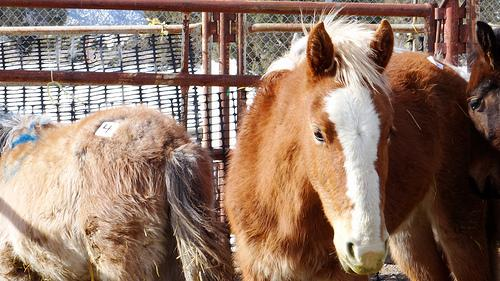Question: when is this taking place?
Choices:
A. Daylight.
B. Halloween.
C. Night time.
D. Dinner time.
Answer with the letter. Answer: A Question: how many ponies are in the photo?
Choices:
A. Two.
B. Four.
C. Five.
D. Three.
Answer with the letter. Answer: D Question: what is the structure surrounding the animals?
Choices:
A. A house.
B. A cage.
C. A barn.
D. Fence.
Answer with the letter. Answer: D Question: what color is the pony on the right side of the photo?
Choices:
A. Black.
B. Brown and white.
C. Tan.
D. Yellow.
Answer with the letter. Answer: B 